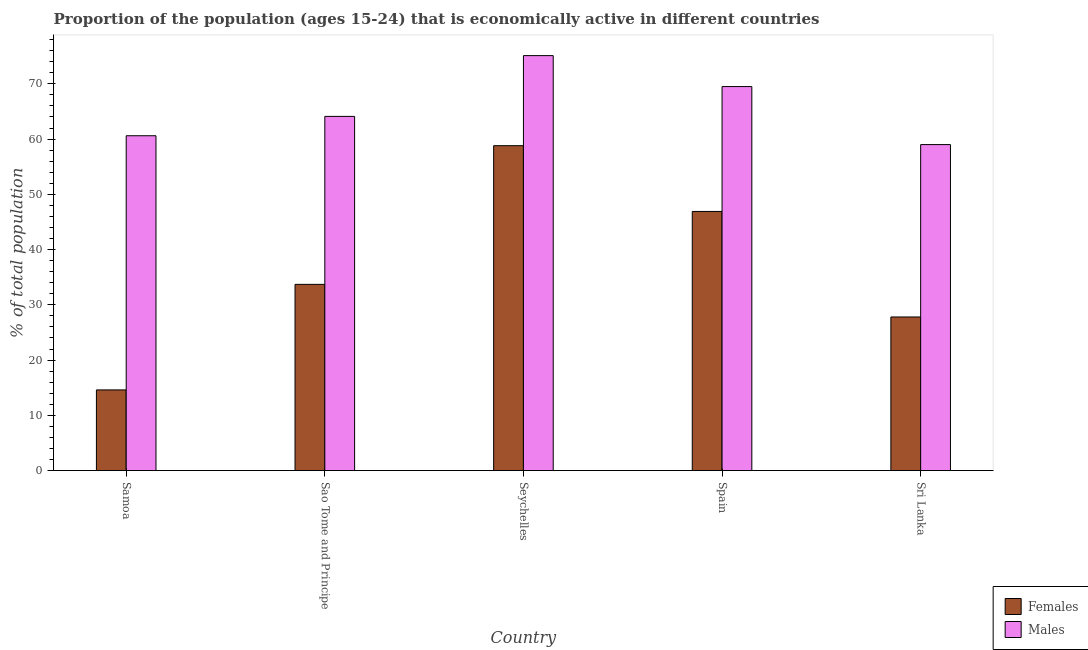How many groups of bars are there?
Make the answer very short. 5. What is the label of the 1st group of bars from the left?
Provide a short and direct response. Samoa. In how many cases, is the number of bars for a given country not equal to the number of legend labels?
Offer a terse response. 0. What is the percentage of economically active female population in Spain?
Give a very brief answer. 46.9. Across all countries, what is the maximum percentage of economically active female population?
Provide a succinct answer. 58.8. Across all countries, what is the minimum percentage of economically active female population?
Ensure brevity in your answer.  14.6. In which country was the percentage of economically active female population maximum?
Make the answer very short. Seychelles. In which country was the percentage of economically active female population minimum?
Your response must be concise. Samoa. What is the total percentage of economically active male population in the graph?
Offer a terse response. 328.3. What is the difference between the percentage of economically active female population in Samoa and that in Spain?
Give a very brief answer. -32.3. What is the difference between the percentage of economically active male population in Seychelles and the percentage of economically active female population in Spain?
Ensure brevity in your answer.  28.2. What is the average percentage of economically active female population per country?
Your answer should be compact. 36.36. What is the difference between the percentage of economically active female population and percentage of economically active male population in Spain?
Your answer should be very brief. -22.6. What is the ratio of the percentage of economically active male population in Samoa to that in Seychelles?
Ensure brevity in your answer.  0.81. Is the percentage of economically active male population in Sao Tome and Principe less than that in Sri Lanka?
Provide a succinct answer. No. Is the difference between the percentage of economically active female population in Sao Tome and Principe and Seychelles greater than the difference between the percentage of economically active male population in Sao Tome and Principe and Seychelles?
Keep it short and to the point. No. What is the difference between the highest and the second highest percentage of economically active female population?
Keep it short and to the point. 11.9. What is the difference between the highest and the lowest percentage of economically active female population?
Your response must be concise. 44.2. In how many countries, is the percentage of economically active female population greater than the average percentage of economically active female population taken over all countries?
Keep it short and to the point. 2. Is the sum of the percentage of economically active female population in Samoa and Sri Lanka greater than the maximum percentage of economically active male population across all countries?
Provide a short and direct response. No. What does the 1st bar from the left in Samoa represents?
Offer a very short reply. Females. What does the 2nd bar from the right in Seychelles represents?
Ensure brevity in your answer.  Females. Are all the bars in the graph horizontal?
Offer a very short reply. No. What is the difference between two consecutive major ticks on the Y-axis?
Keep it short and to the point. 10. Does the graph contain grids?
Make the answer very short. No. Where does the legend appear in the graph?
Your answer should be very brief. Bottom right. How many legend labels are there?
Make the answer very short. 2. How are the legend labels stacked?
Ensure brevity in your answer.  Vertical. What is the title of the graph?
Give a very brief answer. Proportion of the population (ages 15-24) that is economically active in different countries. What is the label or title of the X-axis?
Give a very brief answer. Country. What is the label or title of the Y-axis?
Provide a short and direct response. % of total population. What is the % of total population in Females in Samoa?
Your answer should be very brief. 14.6. What is the % of total population of Males in Samoa?
Give a very brief answer. 60.6. What is the % of total population in Females in Sao Tome and Principe?
Make the answer very short. 33.7. What is the % of total population of Males in Sao Tome and Principe?
Your answer should be compact. 64.1. What is the % of total population in Females in Seychelles?
Offer a very short reply. 58.8. What is the % of total population of Males in Seychelles?
Your answer should be very brief. 75.1. What is the % of total population in Females in Spain?
Provide a short and direct response. 46.9. What is the % of total population in Males in Spain?
Provide a succinct answer. 69.5. What is the % of total population in Females in Sri Lanka?
Give a very brief answer. 27.8. Across all countries, what is the maximum % of total population of Females?
Keep it short and to the point. 58.8. Across all countries, what is the maximum % of total population in Males?
Keep it short and to the point. 75.1. Across all countries, what is the minimum % of total population of Females?
Your response must be concise. 14.6. Across all countries, what is the minimum % of total population of Males?
Offer a very short reply. 59. What is the total % of total population in Females in the graph?
Give a very brief answer. 181.8. What is the total % of total population of Males in the graph?
Provide a short and direct response. 328.3. What is the difference between the % of total population in Females in Samoa and that in Sao Tome and Principe?
Provide a succinct answer. -19.1. What is the difference between the % of total population of Males in Samoa and that in Sao Tome and Principe?
Provide a succinct answer. -3.5. What is the difference between the % of total population in Females in Samoa and that in Seychelles?
Ensure brevity in your answer.  -44.2. What is the difference between the % of total population of Males in Samoa and that in Seychelles?
Offer a terse response. -14.5. What is the difference between the % of total population of Females in Samoa and that in Spain?
Provide a short and direct response. -32.3. What is the difference between the % of total population in Males in Samoa and that in Spain?
Keep it short and to the point. -8.9. What is the difference between the % of total population in Females in Samoa and that in Sri Lanka?
Your answer should be compact. -13.2. What is the difference between the % of total population in Females in Sao Tome and Principe and that in Seychelles?
Offer a terse response. -25.1. What is the difference between the % of total population of Males in Sao Tome and Principe and that in Seychelles?
Provide a succinct answer. -11. What is the difference between the % of total population of Females in Sao Tome and Principe and that in Spain?
Offer a very short reply. -13.2. What is the difference between the % of total population in Females in Sao Tome and Principe and that in Sri Lanka?
Provide a short and direct response. 5.9. What is the difference between the % of total population of Males in Sao Tome and Principe and that in Sri Lanka?
Your answer should be very brief. 5.1. What is the difference between the % of total population in Males in Seychelles and that in Spain?
Offer a terse response. 5.6. What is the difference between the % of total population of Females in Spain and that in Sri Lanka?
Offer a very short reply. 19.1. What is the difference between the % of total population of Females in Samoa and the % of total population of Males in Sao Tome and Principe?
Your answer should be compact. -49.5. What is the difference between the % of total population in Females in Samoa and the % of total population in Males in Seychelles?
Keep it short and to the point. -60.5. What is the difference between the % of total population in Females in Samoa and the % of total population in Males in Spain?
Keep it short and to the point. -54.9. What is the difference between the % of total population of Females in Samoa and the % of total population of Males in Sri Lanka?
Your answer should be compact. -44.4. What is the difference between the % of total population of Females in Sao Tome and Principe and the % of total population of Males in Seychelles?
Offer a very short reply. -41.4. What is the difference between the % of total population of Females in Sao Tome and Principe and the % of total population of Males in Spain?
Keep it short and to the point. -35.8. What is the difference between the % of total population of Females in Sao Tome and Principe and the % of total population of Males in Sri Lanka?
Offer a terse response. -25.3. What is the difference between the % of total population in Females in Seychelles and the % of total population in Males in Spain?
Your answer should be very brief. -10.7. What is the average % of total population of Females per country?
Offer a terse response. 36.36. What is the average % of total population in Males per country?
Provide a short and direct response. 65.66. What is the difference between the % of total population in Females and % of total population in Males in Samoa?
Keep it short and to the point. -46. What is the difference between the % of total population of Females and % of total population of Males in Sao Tome and Principe?
Your response must be concise. -30.4. What is the difference between the % of total population in Females and % of total population in Males in Seychelles?
Provide a succinct answer. -16.3. What is the difference between the % of total population of Females and % of total population of Males in Spain?
Give a very brief answer. -22.6. What is the difference between the % of total population of Females and % of total population of Males in Sri Lanka?
Ensure brevity in your answer.  -31.2. What is the ratio of the % of total population of Females in Samoa to that in Sao Tome and Principe?
Ensure brevity in your answer.  0.43. What is the ratio of the % of total population in Males in Samoa to that in Sao Tome and Principe?
Keep it short and to the point. 0.95. What is the ratio of the % of total population of Females in Samoa to that in Seychelles?
Offer a terse response. 0.25. What is the ratio of the % of total population in Males in Samoa to that in Seychelles?
Ensure brevity in your answer.  0.81. What is the ratio of the % of total population of Females in Samoa to that in Spain?
Offer a very short reply. 0.31. What is the ratio of the % of total population in Males in Samoa to that in Spain?
Your answer should be very brief. 0.87. What is the ratio of the % of total population of Females in Samoa to that in Sri Lanka?
Make the answer very short. 0.53. What is the ratio of the % of total population of Males in Samoa to that in Sri Lanka?
Provide a short and direct response. 1.03. What is the ratio of the % of total population in Females in Sao Tome and Principe to that in Seychelles?
Your answer should be very brief. 0.57. What is the ratio of the % of total population of Males in Sao Tome and Principe to that in Seychelles?
Provide a succinct answer. 0.85. What is the ratio of the % of total population of Females in Sao Tome and Principe to that in Spain?
Ensure brevity in your answer.  0.72. What is the ratio of the % of total population in Males in Sao Tome and Principe to that in Spain?
Offer a terse response. 0.92. What is the ratio of the % of total population in Females in Sao Tome and Principe to that in Sri Lanka?
Your answer should be compact. 1.21. What is the ratio of the % of total population of Males in Sao Tome and Principe to that in Sri Lanka?
Your response must be concise. 1.09. What is the ratio of the % of total population of Females in Seychelles to that in Spain?
Offer a terse response. 1.25. What is the ratio of the % of total population in Males in Seychelles to that in Spain?
Keep it short and to the point. 1.08. What is the ratio of the % of total population of Females in Seychelles to that in Sri Lanka?
Provide a succinct answer. 2.12. What is the ratio of the % of total population of Males in Seychelles to that in Sri Lanka?
Keep it short and to the point. 1.27. What is the ratio of the % of total population in Females in Spain to that in Sri Lanka?
Give a very brief answer. 1.69. What is the ratio of the % of total population in Males in Spain to that in Sri Lanka?
Your answer should be very brief. 1.18. What is the difference between the highest and the second highest % of total population of Females?
Provide a succinct answer. 11.9. What is the difference between the highest and the lowest % of total population in Females?
Give a very brief answer. 44.2. 